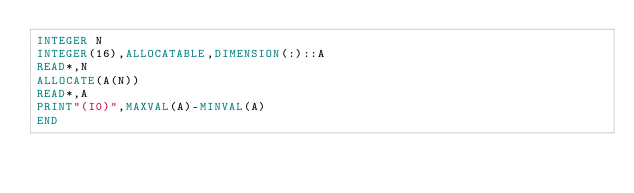<code> <loc_0><loc_0><loc_500><loc_500><_FORTRAN_>INTEGER N
INTEGER(16),ALLOCATABLE,DIMENSION(:)::A
READ*,N
ALLOCATE(A(N))
READ*,A
PRINT"(I0)",MAXVAL(A)-MINVAL(A)
END</code> 